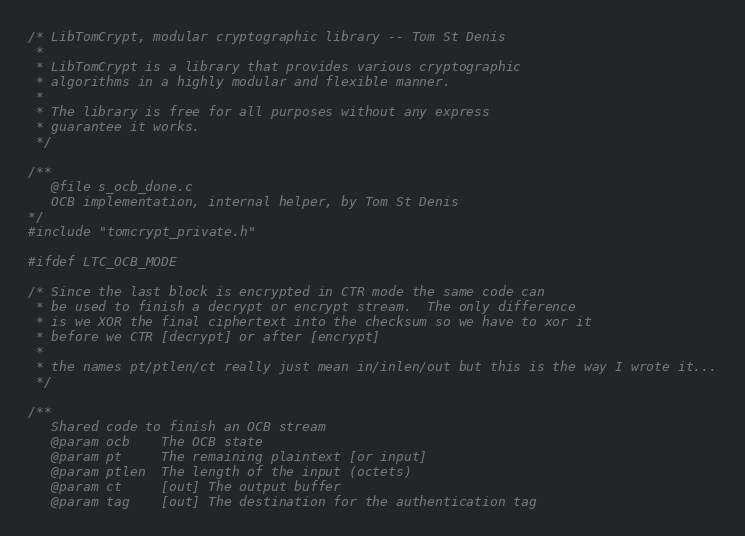<code> <loc_0><loc_0><loc_500><loc_500><_C_>/* LibTomCrypt, modular cryptographic library -- Tom St Denis
 *
 * LibTomCrypt is a library that provides various cryptographic
 * algorithms in a highly modular and flexible manner.
 *
 * The library is free for all purposes without any express
 * guarantee it works.
 */

/**
   @file s_ocb_done.c
   OCB implementation, internal helper, by Tom St Denis
*/
#include "tomcrypt_private.h"

#ifdef LTC_OCB_MODE

/* Since the last block is encrypted in CTR mode the same code can
 * be used to finish a decrypt or encrypt stream.  The only difference
 * is we XOR the final ciphertext into the checksum so we have to xor it
 * before we CTR [decrypt] or after [encrypt]
 *
 * the names pt/ptlen/ct really just mean in/inlen/out but this is the way I wrote it...
 */

/**
   Shared code to finish an OCB stream
   @param ocb    The OCB state
   @param pt     The remaining plaintext [or input]
   @param ptlen  The length of the input (octets)
   @param ct     [out] The output buffer
   @param tag    [out] The destination for the authentication tag</code> 